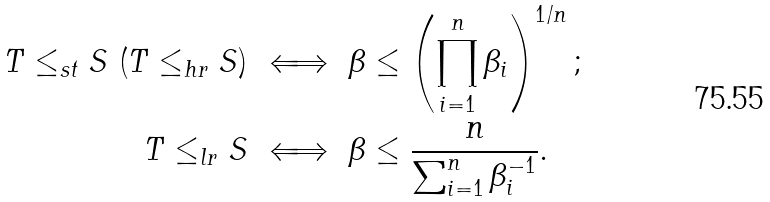Convert formula to latex. <formula><loc_0><loc_0><loc_500><loc_500>T \leq _ { s t } S \ ( T \leq _ { h r } S ) \ & \Longleftrightarrow \ \beta \leq \left ( \prod _ { i = 1 } ^ { n } \beta _ { i } \right ) ^ { 1 / n } ; \\ T \leq _ { l r } S \ & \Longleftrightarrow \ \beta \leq \frac { n } { \sum _ { i = 1 } ^ { n } \beta _ { i } ^ { - 1 } } .</formula> 